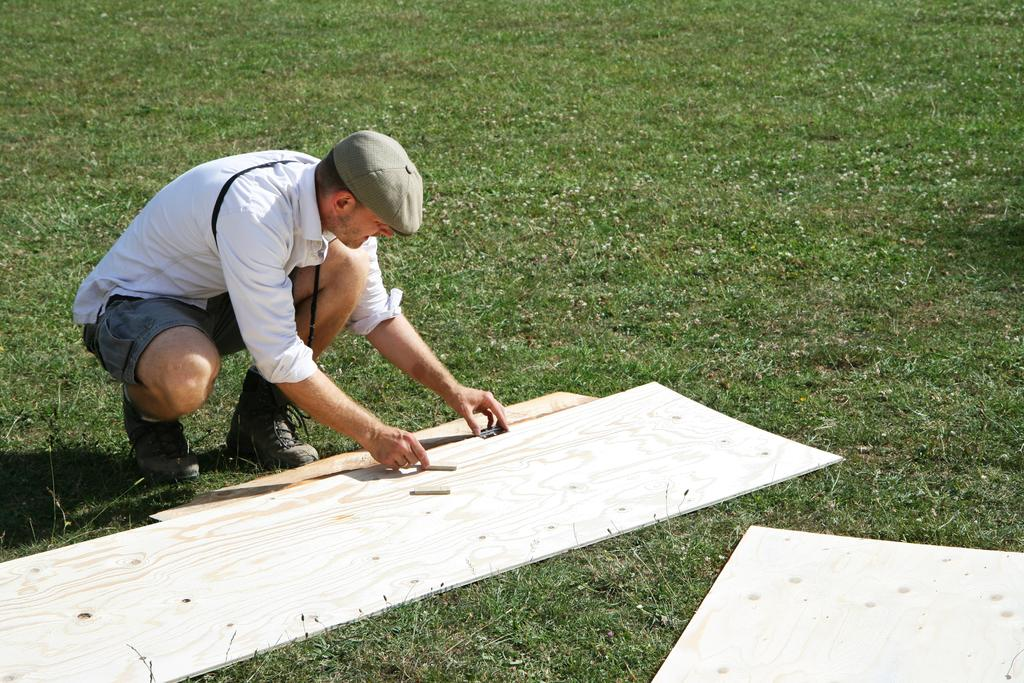What is the main subject of the image? There is a person sitting in the center of the image. What is the person sitting on? The person is sitting on a cardboard. What type of environment is visible in the background of the image? There is grass visible in the background of the image. What type of meal is being served on the stage in the image? There is no stage or meal present in the image; it features a person sitting on a cardboard with grass visible in the background. 